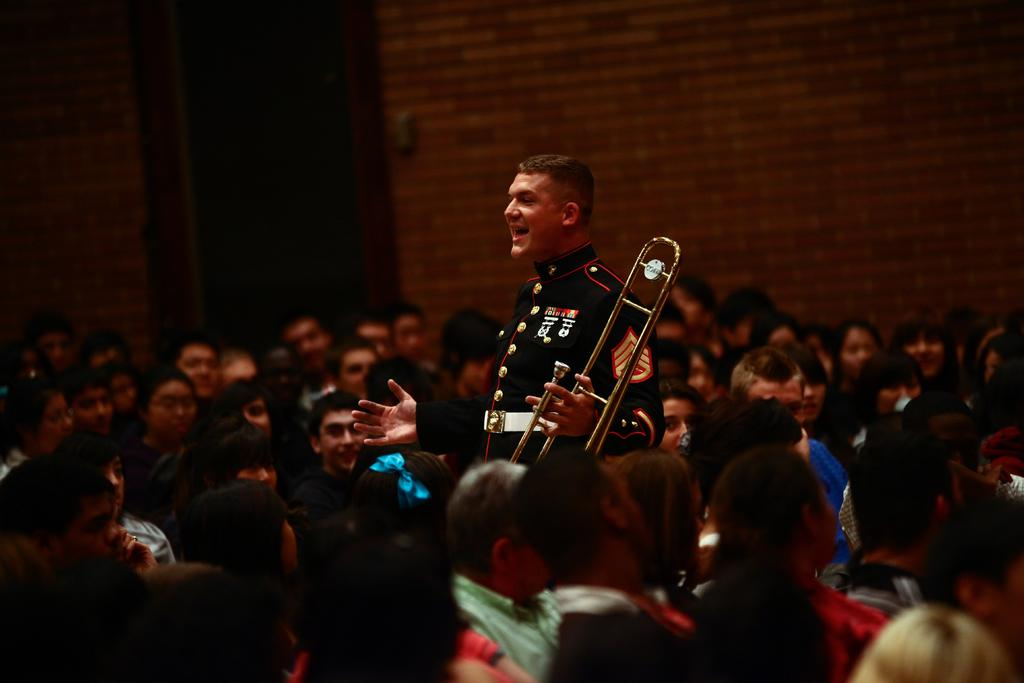What are the people in the image doing? The people in the image are seated. What are the people seated on? The people are seated on chairs. Is there anyone standing in the image? Yes, there is a man standing in the image. What is the man holding in his hand? The man is holding a trumpet in his hand. What type of heat source is present in the image? There is no heat source present in the image. What type of space vehicle can be seen in the image? There is no space vehicle present in the image. 